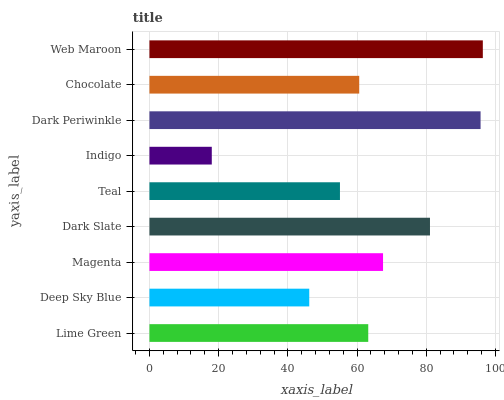Is Indigo the minimum?
Answer yes or no. Yes. Is Web Maroon the maximum?
Answer yes or no. Yes. Is Deep Sky Blue the minimum?
Answer yes or no. No. Is Deep Sky Blue the maximum?
Answer yes or no. No. Is Lime Green greater than Deep Sky Blue?
Answer yes or no. Yes. Is Deep Sky Blue less than Lime Green?
Answer yes or no. Yes. Is Deep Sky Blue greater than Lime Green?
Answer yes or no. No. Is Lime Green less than Deep Sky Blue?
Answer yes or no. No. Is Lime Green the high median?
Answer yes or no. Yes. Is Lime Green the low median?
Answer yes or no. Yes. Is Deep Sky Blue the high median?
Answer yes or no. No. Is Magenta the low median?
Answer yes or no. No. 